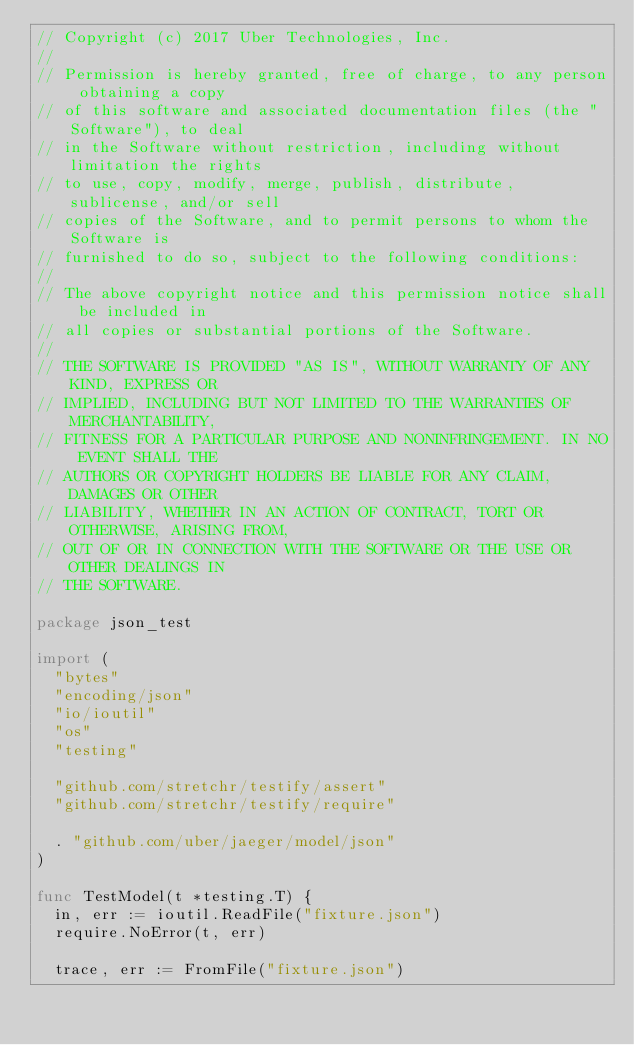<code> <loc_0><loc_0><loc_500><loc_500><_Go_>// Copyright (c) 2017 Uber Technologies, Inc.
//
// Permission is hereby granted, free of charge, to any person obtaining a copy
// of this software and associated documentation files (the "Software"), to deal
// in the Software without restriction, including without limitation the rights
// to use, copy, modify, merge, publish, distribute, sublicense, and/or sell
// copies of the Software, and to permit persons to whom the Software is
// furnished to do so, subject to the following conditions:
//
// The above copyright notice and this permission notice shall be included in
// all copies or substantial portions of the Software.
//
// THE SOFTWARE IS PROVIDED "AS IS", WITHOUT WARRANTY OF ANY KIND, EXPRESS OR
// IMPLIED, INCLUDING BUT NOT LIMITED TO THE WARRANTIES OF MERCHANTABILITY,
// FITNESS FOR A PARTICULAR PURPOSE AND NONINFRINGEMENT. IN NO EVENT SHALL THE
// AUTHORS OR COPYRIGHT HOLDERS BE LIABLE FOR ANY CLAIM, DAMAGES OR OTHER
// LIABILITY, WHETHER IN AN ACTION OF CONTRACT, TORT OR OTHERWISE, ARISING FROM,
// OUT OF OR IN CONNECTION WITH THE SOFTWARE OR THE USE OR OTHER DEALINGS IN
// THE SOFTWARE.

package json_test

import (
	"bytes"
	"encoding/json"
	"io/ioutil"
	"os"
	"testing"

	"github.com/stretchr/testify/assert"
	"github.com/stretchr/testify/require"

	. "github.com/uber/jaeger/model/json"
)

func TestModel(t *testing.T) {
	in, err := ioutil.ReadFile("fixture.json")
	require.NoError(t, err)

	trace, err := FromFile("fixture.json")</code> 